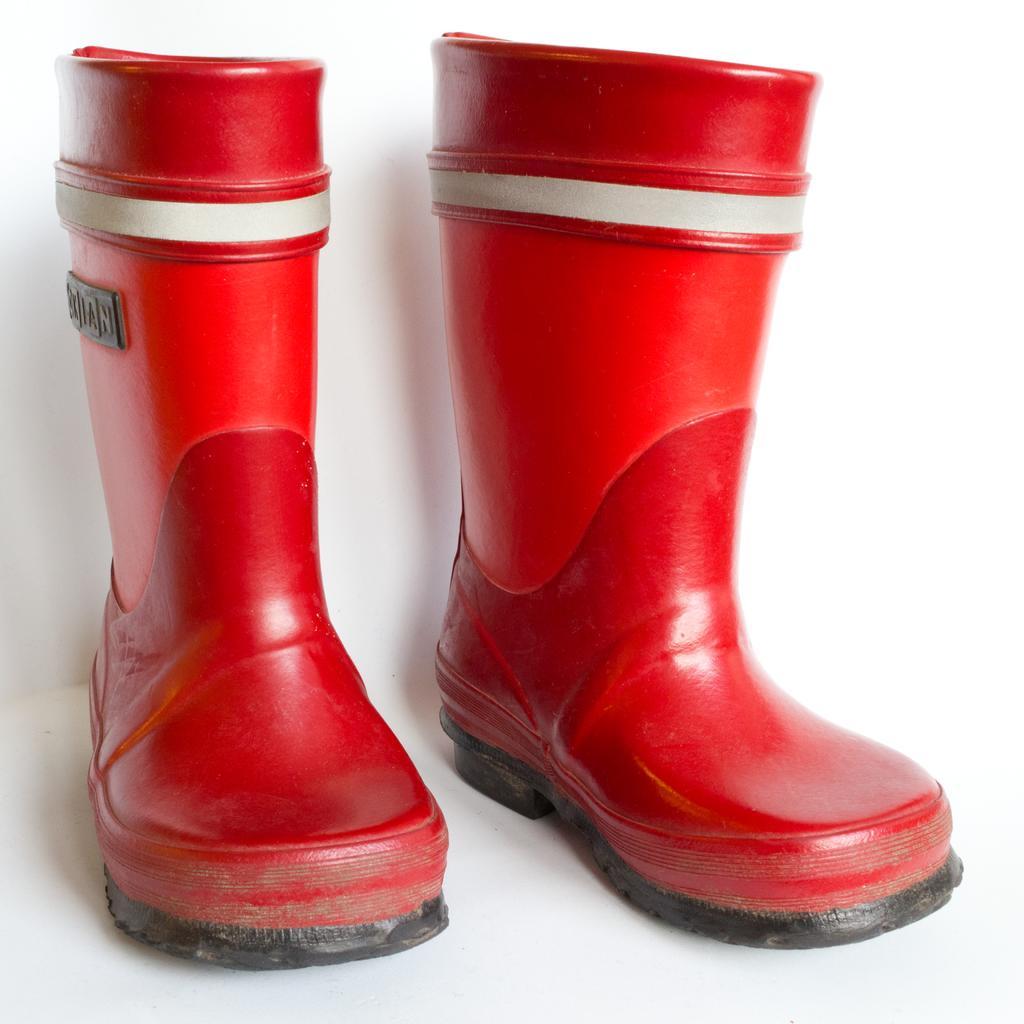Could you give a brief overview of what you see in this image? In this image we can see two red color boots on the white surface. 